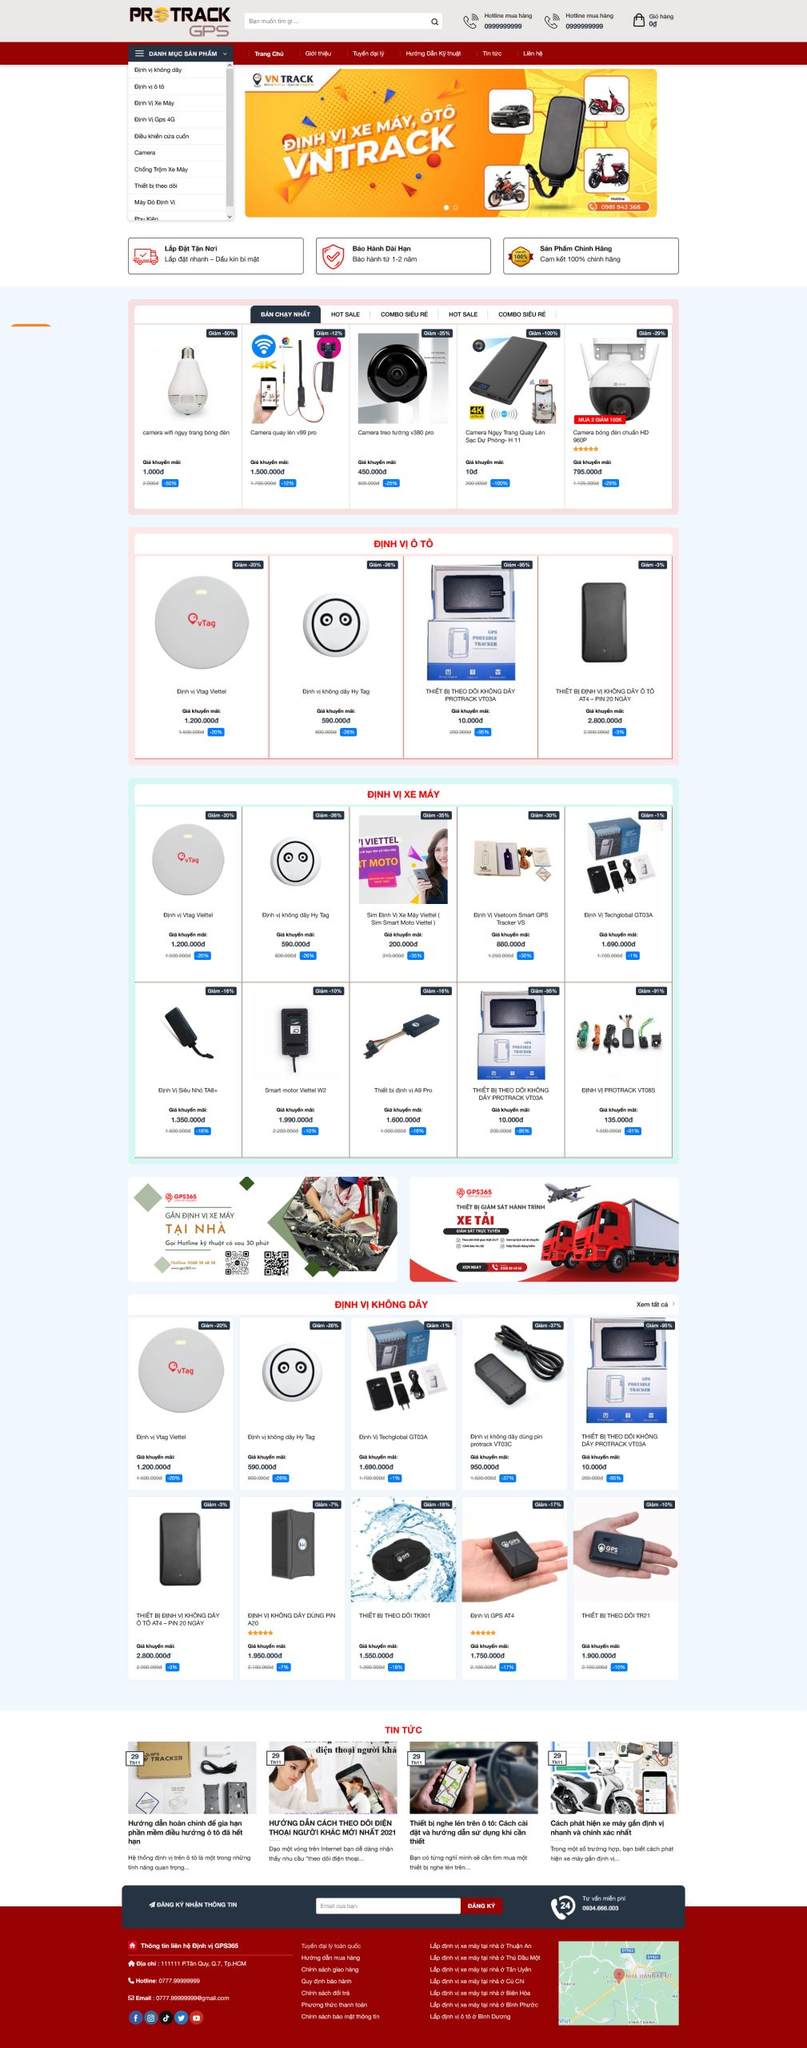Liệt kê 5 ngành nghề, lĩnh vực phù hợp với website này, phân cách các màu sắc bằng dấu phẩy. Chỉ trả về kết quả, phân cách bằng dấy phẩy
 Định vị xe máy, Định vị ô tô, Camera giám sát, Thiết bị thông minh, An ninh gia đình 